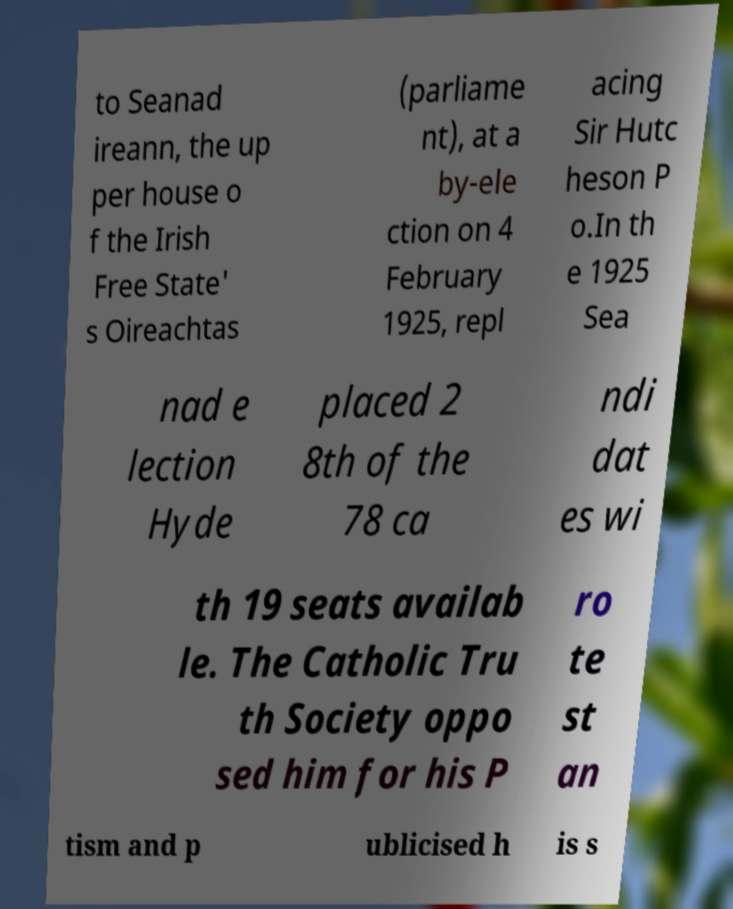There's text embedded in this image that I need extracted. Can you transcribe it verbatim? to Seanad ireann, the up per house o f the Irish Free State' s Oireachtas (parliame nt), at a by-ele ction on 4 February 1925, repl acing Sir Hutc heson P o.In th e 1925 Sea nad e lection Hyde placed 2 8th of the 78 ca ndi dat es wi th 19 seats availab le. The Catholic Tru th Society oppo sed him for his P ro te st an tism and p ublicised h is s 